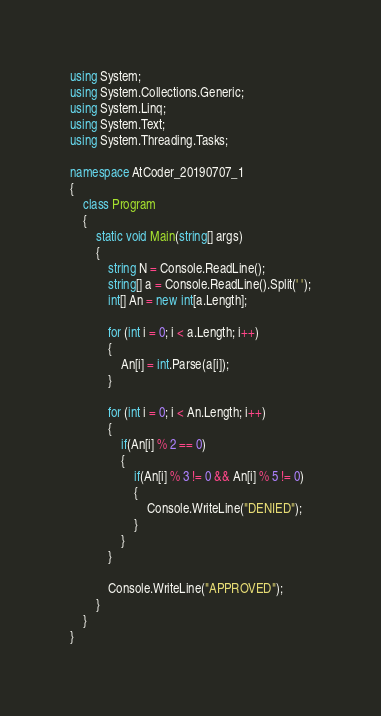<code> <loc_0><loc_0><loc_500><loc_500><_C#_>using System;
using System.Collections.Generic;
using System.Linq;
using System.Text;
using System.Threading.Tasks;

namespace AtCoder_20190707_1
{
    class Program
    {
        static void Main(string[] args)
        {
            string N = Console.ReadLine();
            string[] a = Console.ReadLine().Split(' ');
            int[] An = new int[a.Length];

            for (int i = 0; i < a.Length; i++)
            {
                An[i] = int.Parse(a[i]);
            }

            for (int i = 0; i < An.Length; i++)
            {
                if(An[i] % 2 == 0)
                {
                    if(An[i] % 3 != 0 && An[i] % 5 != 0)
                    {
                        Console.WriteLine("DENIED");
                    }
                }
            }

            Console.WriteLine("APPROVED");
        }
    }
}
</code> 